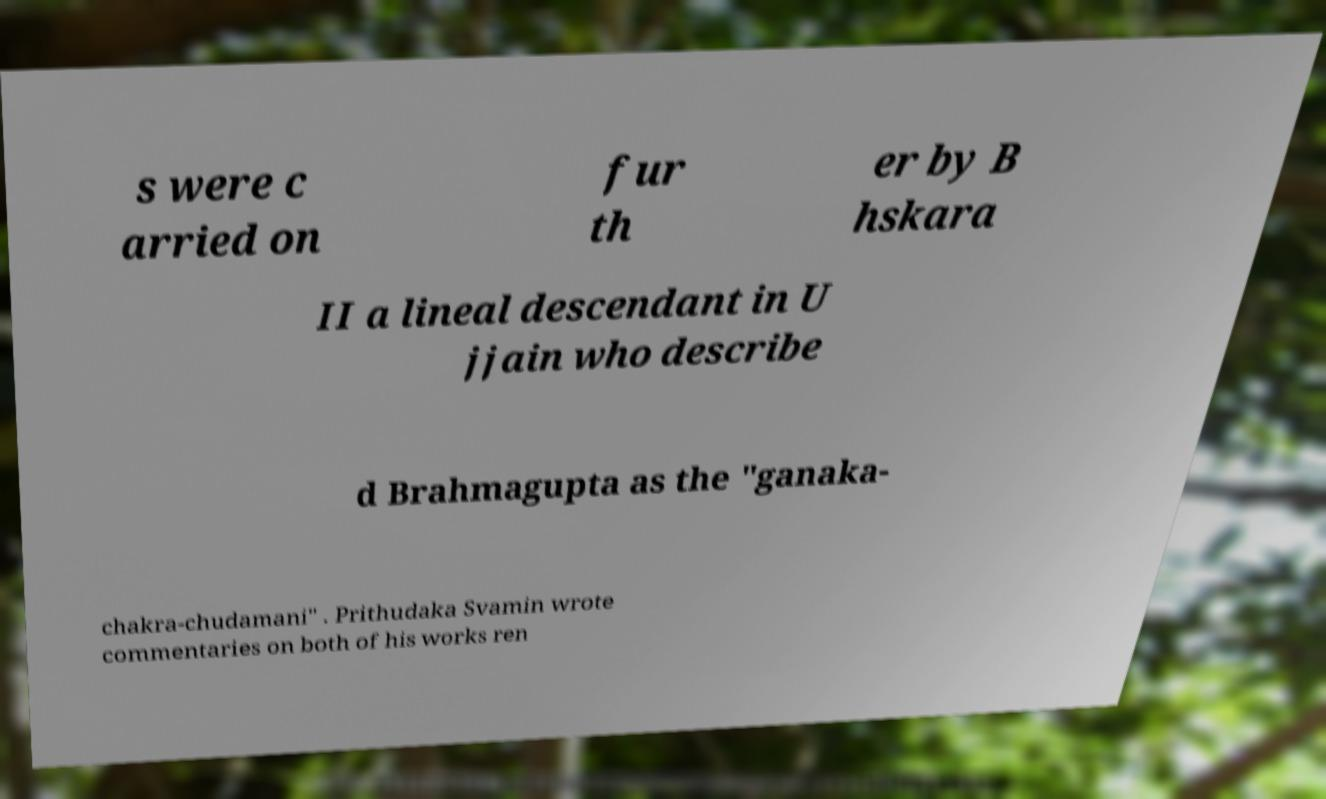Please identify and transcribe the text found in this image. s were c arried on fur th er by B hskara II a lineal descendant in U jjain who describe d Brahmagupta as the "ganaka- chakra-chudamani" . Prithudaka Svamin wrote commentaries on both of his works ren 